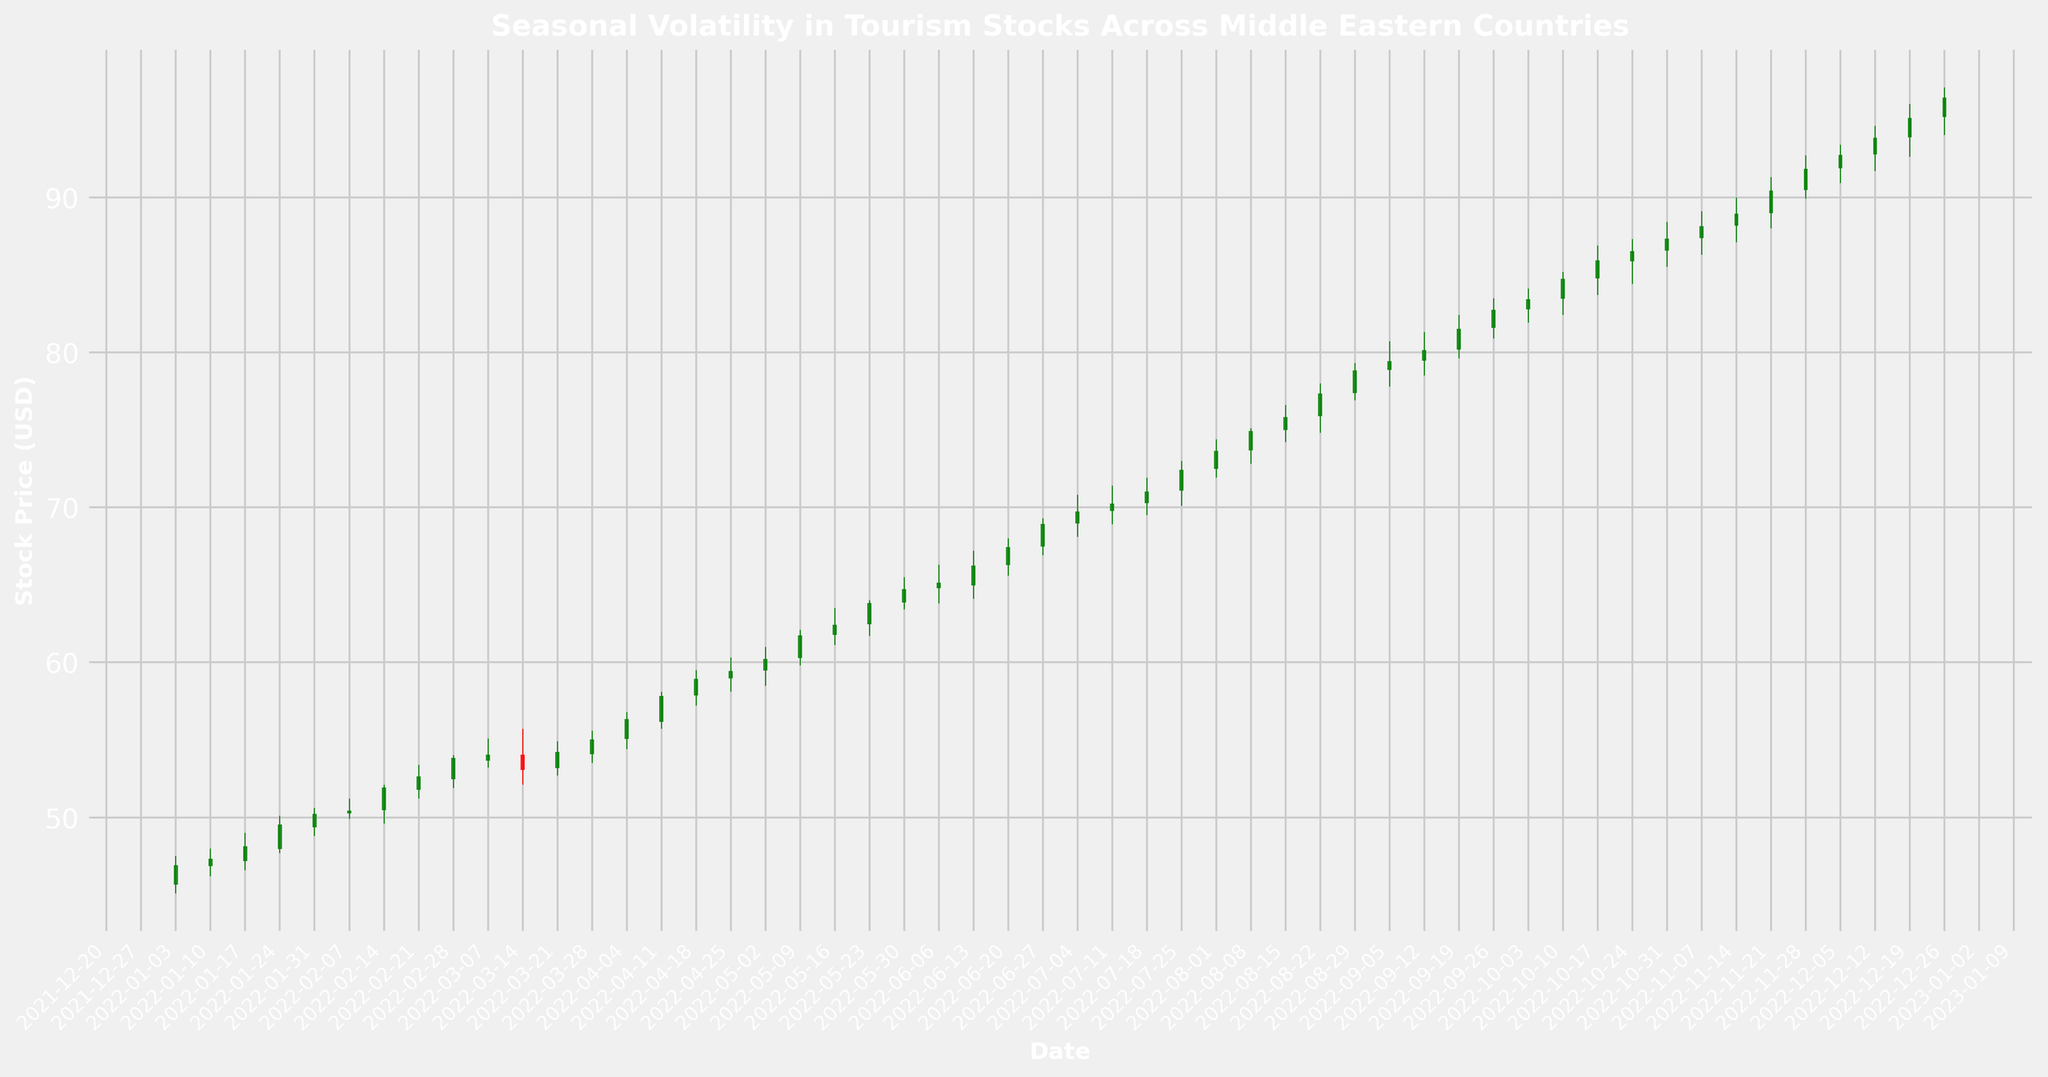What is the date range during which the stock price consistently increased without drop? From the plot, observe the trend of the candlestick chart and identify periods where the closing price increases every week without any drop. This occurs between January 3rd, 2022 and March 28th, 2022.
Answer: January 3rd to March 28th Which month recorded the highest closing stock price? Look for the highest point in the candlestick chart where the closing price occurs. This is visually identifiable in December 2022.
Answer: December During which months did the stock price show the most significant growth? Identify steep upward trends within the candlestick chart. Notably, the stock price exhibited significant growth during May 2022 and July 2022.
Answer: May, July When did the stock price experience a significant drop, and how does it visually appear on the chart? Look for a red candlestick (indicating a drop) that is significantly longer than others. A notable drop occurs around mid-March 2022.
Answer: Mid-March, red candlestick What's the average closing stock price for the months of June and July? Find the closing prices for each week of June and July. Sum these values and divide by the number of weeks: (June: 65.1, 66.2, 67.4, 68.9; July: 69.7, 70.2, 71.0, 72.4). So, the average would be (65.1 + 66.2 + 67.4 + 68.9 + 69.7 + 70.2 + 71.0 + 72.4) / 8 = 69.0.
Answer: 69.0 Compare the closing price at the beginning of the year (January) with the end of the year (December). Which one is higher and by how much? Note the closing price on January 3rd (46.9) and December 26th (96.4), then subtract January’s close from December’s close: 96.4 - 46.9 = 49.5. December’s closing price is higher by 49.5.
Answer: December higher by 49.5 What was the stock price trend from October to December? Observe the candlestick trends from October to December. The trend shows an upward movement.
Answer: Upward movement Which month had the highest trading volume, and what is the significance of this in the context of stock price volatility? Look for the month with the tallest volume bars. The highest volume is in December, indicating higher investor activity and potential volatility in stock prices.
Answer: December, indicates high volatility What is the opening price trend for the entire year? Look at the starting point of each candlestick throughout the year to evaluate trends. The opening prices generally trend upwards throughout 2022.
Answer: Upward trend How many weeks did the stock maintain an upward trend without a significant drop in March? Check the weekly candlesticks for March. There are 4 weeks, and the trend remains upward except for a significant drop in mid-March.
Answer: 3 weeks 